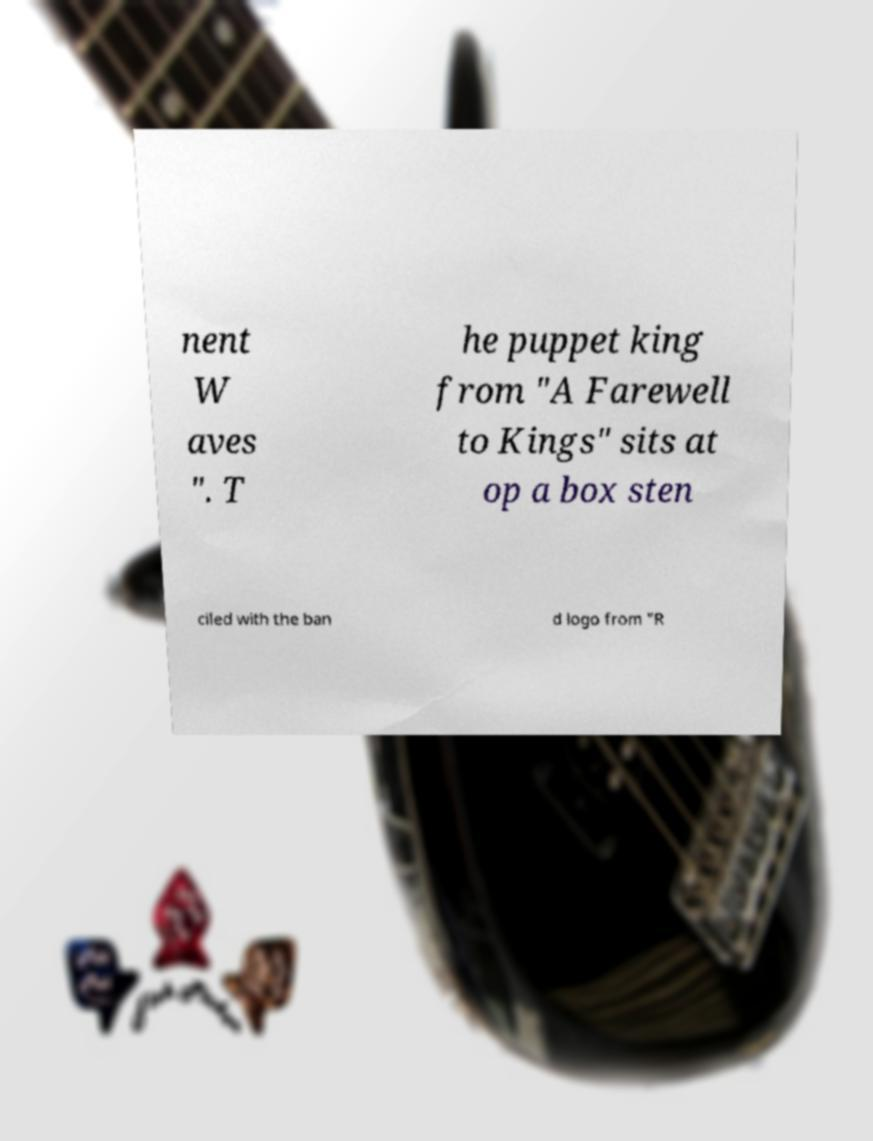Please identify and transcribe the text found in this image. nent W aves ". T he puppet king from "A Farewell to Kings" sits at op a box sten ciled with the ban d logo from "R 